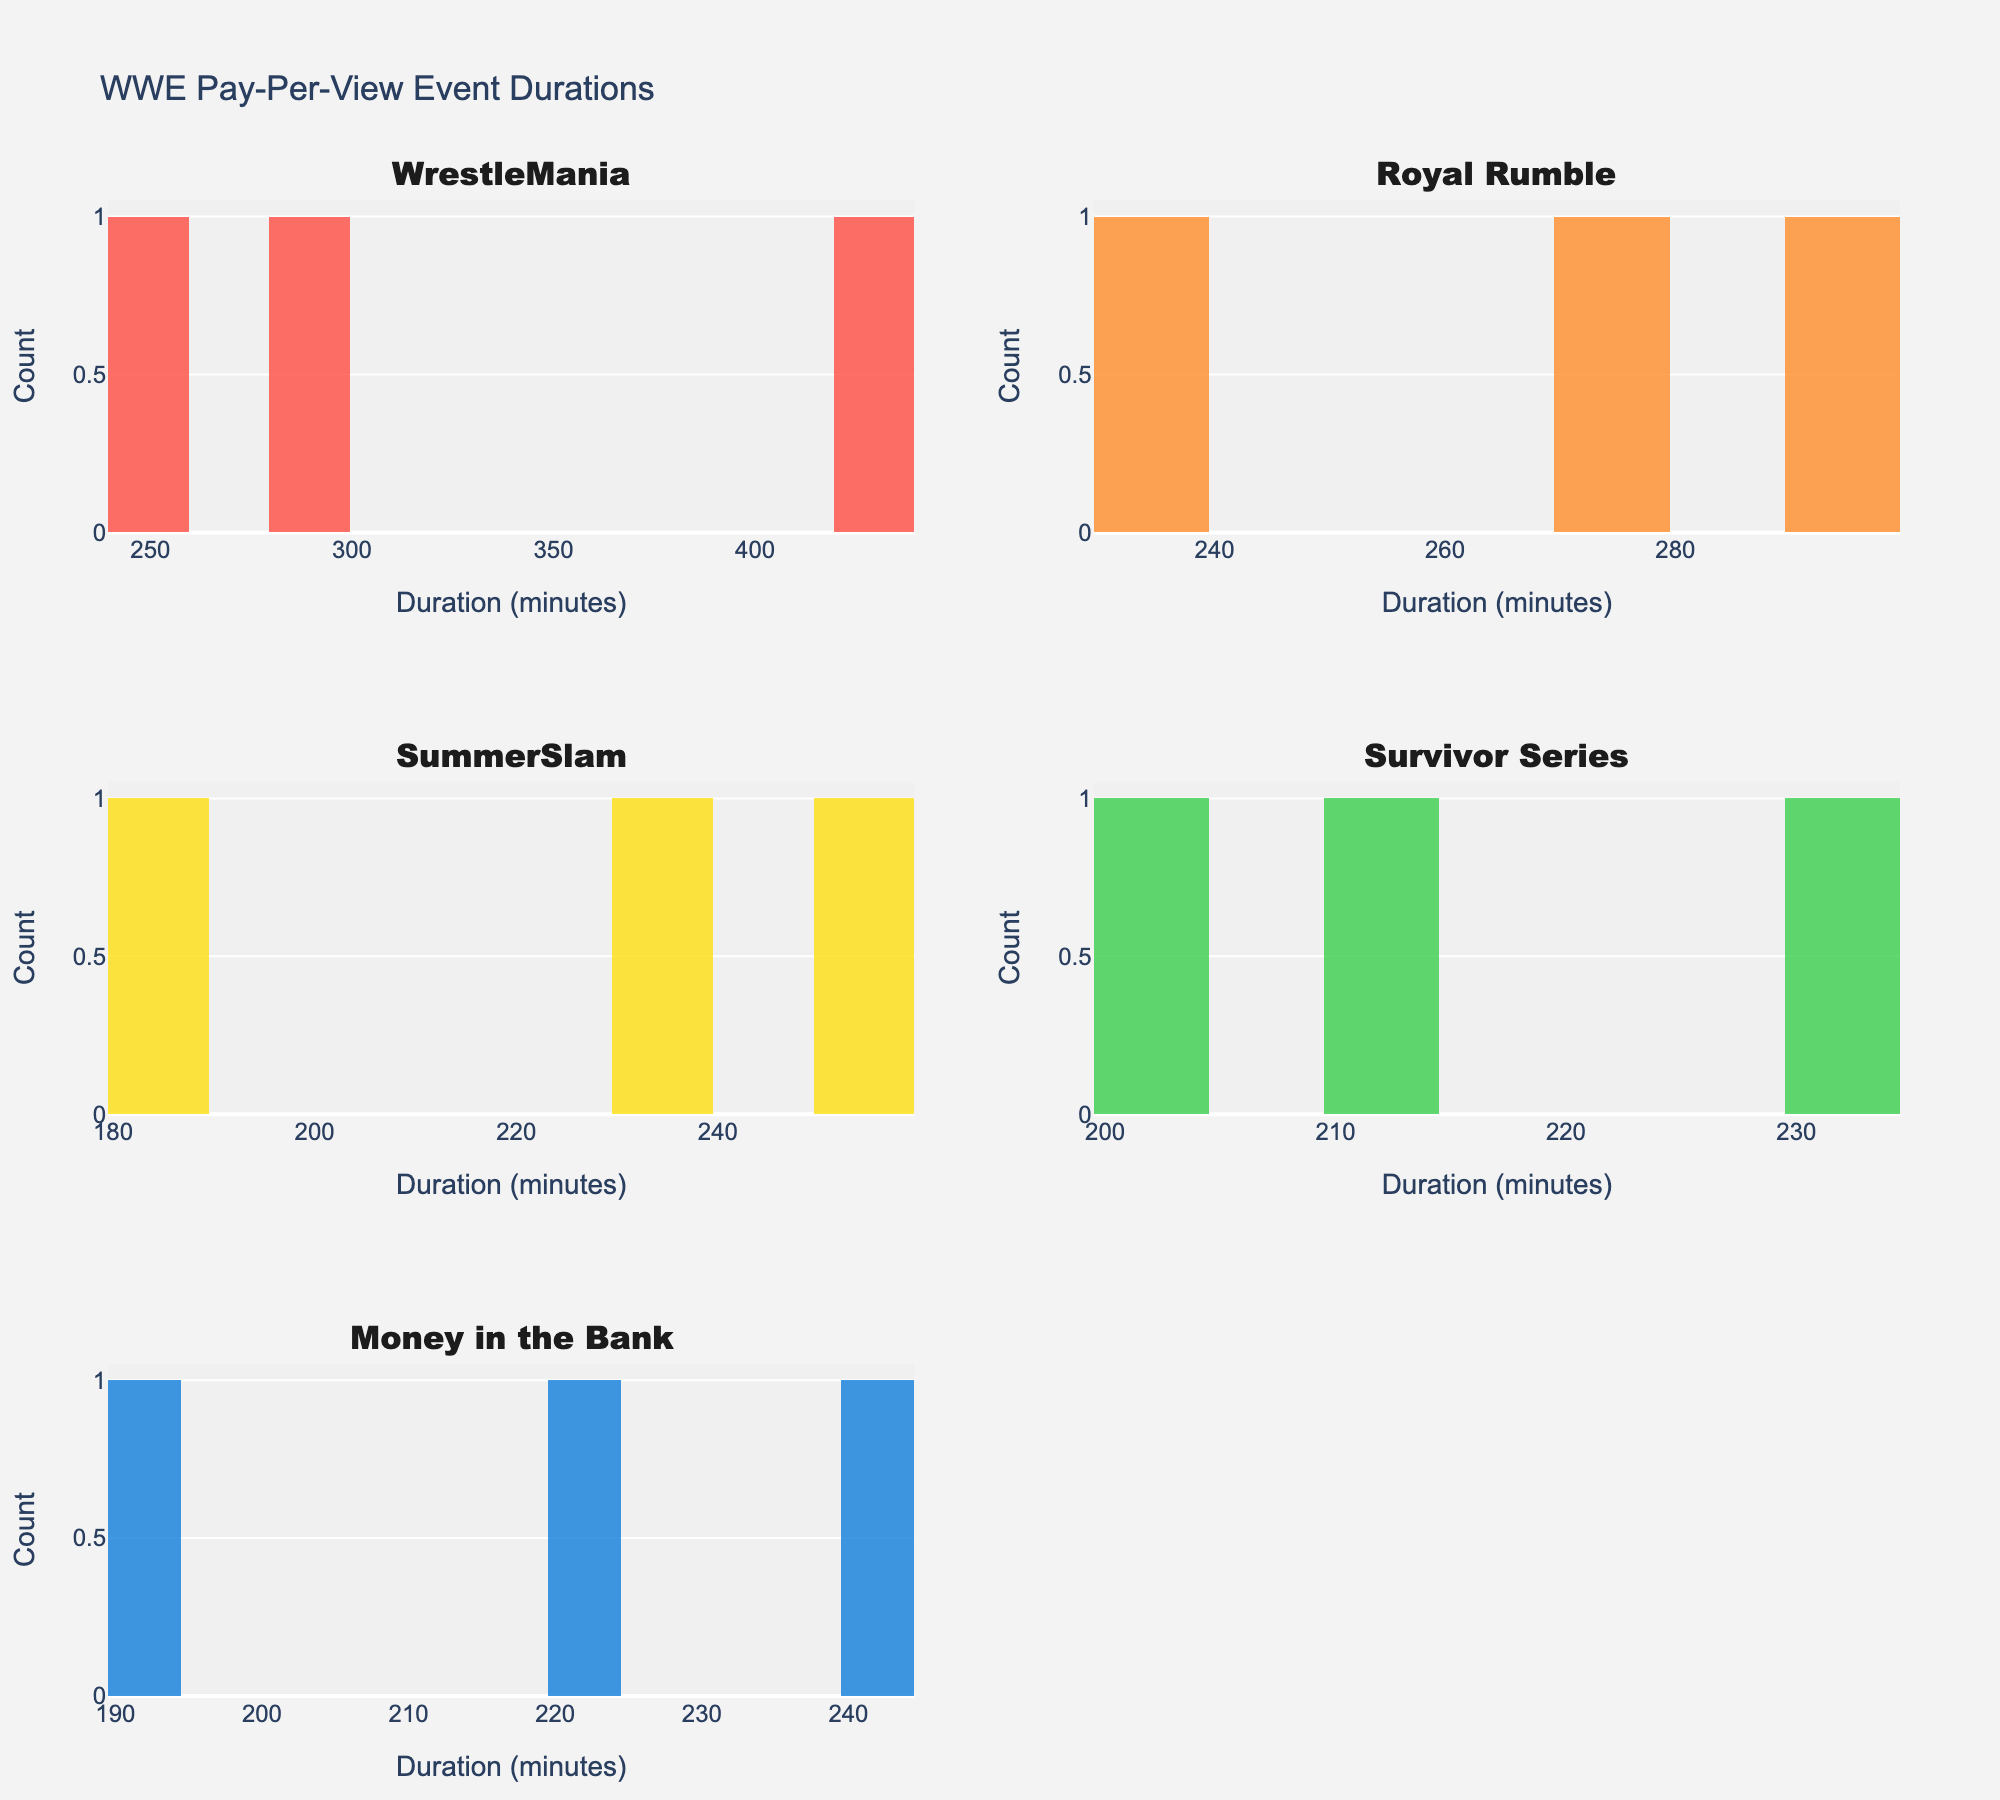Which event type has the highest number of pay-per-view events shown in the histograms? The histograms display counts of event durations for each event type. By visually inspecting the histograms, WrestleMania appears to have the highest count of bars, indicating the most pay-per-view events.
Answer: WrestleMania What is the range of durations for WrestleMania events? Looking at the histogram subplot for WrestleMania, the duration spans from just above 200 minutes to around 450 minutes (since there's a bar at the 400+ range).
Answer: Approximately 200-450 minutes Which event type shows the smallest range of event durations? By inspecting the width of the bars for each histogram, the smallest range appears in Survivor Series, as its durations cluster around a narrow band between approximately 200 to 230 minutes.
Answer: Survivor Series Which two event types have at least one event lasting more than 300 minutes? By checking the rightmost bars of each histogram, only WrestleMania and Royal Rumble have bars extending beyond the 300-minute mark.
Answer: WrestleMania and Royal Rumble How many event types have their largest number of events in the duration range of 200 to 250 minutes? Counting the bars in the range from 200 to 250 minutes for all histograms, WrestleMania, Royal Rumble, SummerSlam, Survivor Series, and Money in the Bank each show the highest bar counts. This makes it five event types.
Answer: Five What is the average duration of WrestleMania events? By adding the durations of the three WrestleMania events (427, 243, 284) and dividing by the number of events (3), we get the average: (427 + 243 + 284) / 3 = 318 minutes.
Answer: 318 minutes Which event type generally has shorter durations than others? Comparing the histograms visually, SummerSlam events tend to hover around shorter durations compared to WrestleMania and Royal Rumble, indicating generally shorter events.
Answer: SummerSlam Between Royal Rumble and SummerSlam, which has more events in the 250-300 minutes range? By comparing the height of the bars in the 250-300 minute range, Royal Rumble has a higher count of bars than SummerSlam.
Answer: Royal Rumble What is the maximum duration of Royal Rumble events? Looking at the furthest right bar in the Royal Rumble histogram, the maximum duration is around 290 minutes.
Answer: 290 minutes 